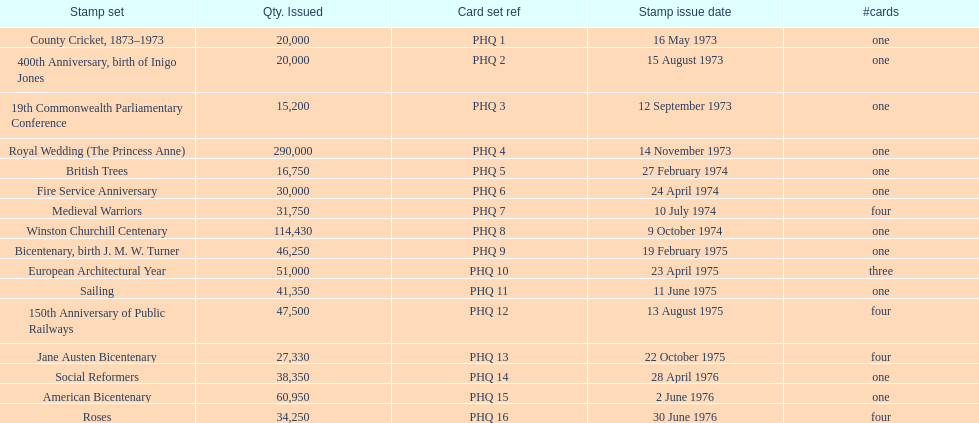I'm looking to parse the entire table for insights. Could you assist me with that? {'header': ['Stamp set', 'Qty. Issued', 'Card set ref', 'Stamp issue date', '#cards'], 'rows': [['County Cricket, 1873–1973', '20,000', 'PHQ 1', '16 May 1973', 'one'], ['400th Anniversary, birth of Inigo Jones', '20,000', 'PHQ 2', '15 August 1973', 'one'], ['19th Commonwealth Parliamentary Conference', '15,200', 'PHQ 3', '12 September 1973', 'one'], ['Royal Wedding (The Princess Anne)', '290,000', 'PHQ 4', '14 November 1973', 'one'], ['British Trees', '16,750', 'PHQ 5', '27 February 1974', 'one'], ['Fire Service Anniversary', '30,000', 'PHQ 6', '24 April 1974', 'one'], ['Medieval Warriors', '31,750', 'PHQ 7', '10 July 1974', 'four'], ['Winston Churchill Centenary', '114,430', 'PHQ 8', '9 October 1974', 'one'], ['Bicentenary, birth J. M. W. Turner', '46,250', 'PHQ 9', '19 February 1975', 'one'], ['European Architectural Year', '51,000', 'PHQ 10', '23 April 1975', 'three'], ['Sailing', '41,350', 'PHQ 11', '11 June 1975', 'one'], ['150th Anniversary of Public Railways', '47,500', 'PHQ 12', '13 August 1975', 'four'], ['Jane Austen Bicentenary', '27,330', 'PHQ 13', '22 October 1975', 'four'], ['Social Reformers', '38,350', 'PHQ 14', '28 April 1976', 'one'], ['American Bicentenary', '60,950', 'PHQ 15', '2 June 1976', 'one'], ['Roses', '34,250', 'PHQ 16', '30 June 1976', 'four']]} Which year had the most stamps issued? 1973. 